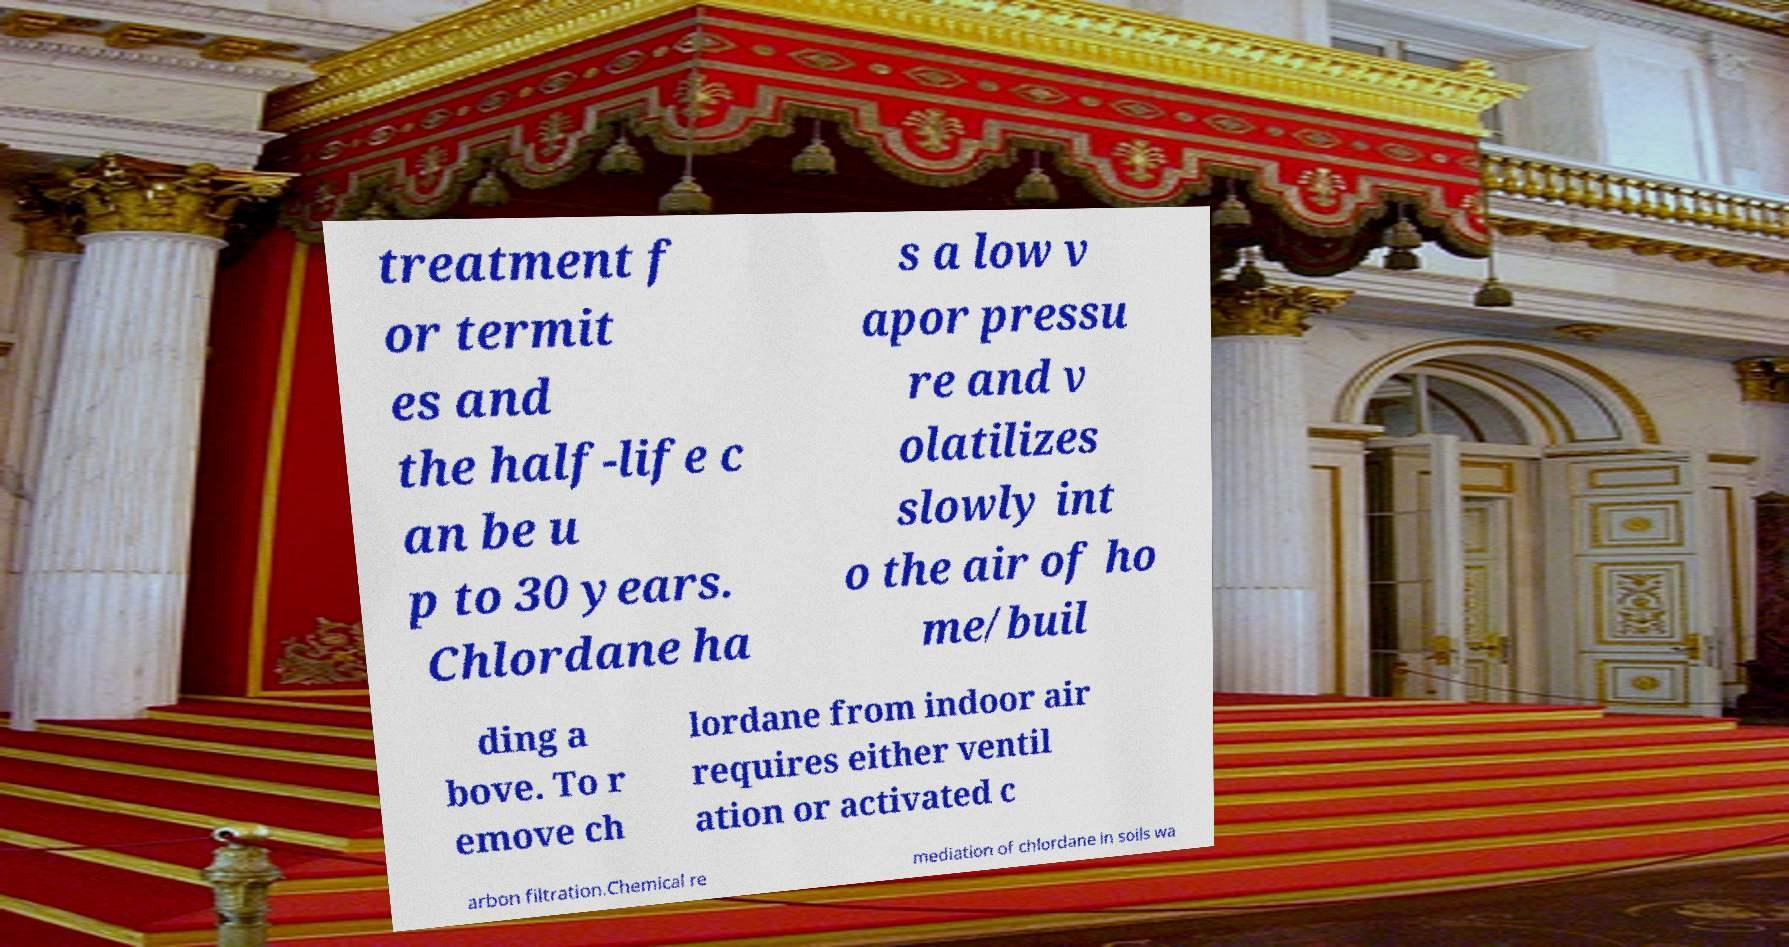Could you assist in decoding the text presented in this image and type it out clearly? treatment f or termit es and the half-life c an be u p to 30 years. Chlordane ha s a low v apor pressu re and v olatilizes slowly int o the air of ho me/buil ding a bove. To r emove ch lordane from indoor air requires either ventil ation or activated c arbon filtration.Chemical re mediation of chlordane in soils wa 